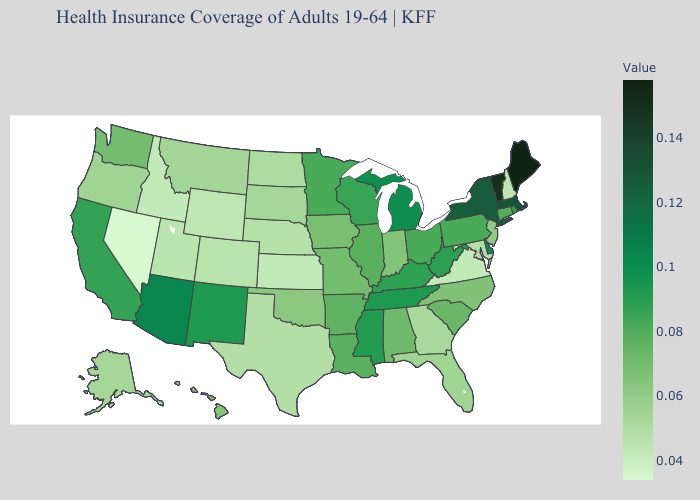Among the states that border Nevada , which have the lowest value?
Give a very brief answer. Idaho. Does Georgia have the lowest value in the USA?
Be succinct. No. Does Arizona have the lowest value in the West?
Keep it brief. No. Does Delaware have the highest value in the South?
Be succinct. Yes. Does Nevada have the lowest value in the USA?
Quick response, please. Yes. 